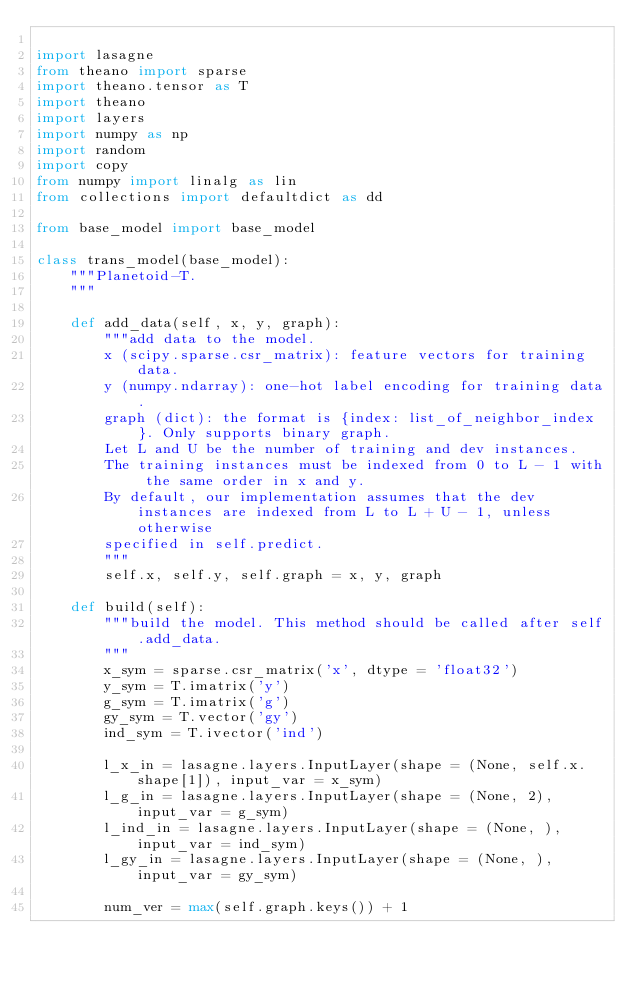Convert code to text. <code><loc_0><loc_0><loc_500><loc_500><_Python_>
import lasagne
from theano import sparse
import theano.tensor as T
import theano
import layers
import numpy as np
import random
import copy
from numpy import linalg as lin
from collections import defaultdict as dd

from base_model import base_model

class trans_model(base_model):
    """Planetoid-T.
    """

    def add_data(self, x, y, graph):
        """add data to the model.
        x (scipy.sparse.csr_matrix): feature vectors for training data.
        y (numpy.ndarray): one-hot label encoding for training data.
        graph (dict): the format is {index: list_of_neighbor_index}. Only supports binary graph.
        Let L and U be the number of training and dev instances.
        The training instances must be indexed from 0 to L - 1 with the same order in x and y.
        By default, our implementation assumes that the dev instances are indexed from L to L + U - 1, unless otherwise
        specified in self.predict.
        """
        self.x, self.y, self.graph = x, y, graph

    def build(self):
        """build the model. This method should be called after self.add_data.
        """
        x_sym = sparse.csr_matrix('x', dtype = 'float32')
        y_sym = T.imatrix('y')
        g_sym = T.imatrix('g')
        gy_sym = T.vector('gy')
        ind_sym = T.ivector('ind')

        l_x_in = lasagne.layers.InputLayer(shape = (None, self.x.shape[1]), input_var = x_sym)
        l_g_in = lasagne.layers.InputLayer(shape = (None, 2), input_var = g_sym)
        l_ind_in = lasagne.layers.InputLayer(shape = (None, ), input_var = ind_sym)
        l_gy_in = lasagne.layers.InputLayer(shape = (None, ), input_var = gy_sym)

        num_ver = max(self.graph.keys()) + 1</code> 